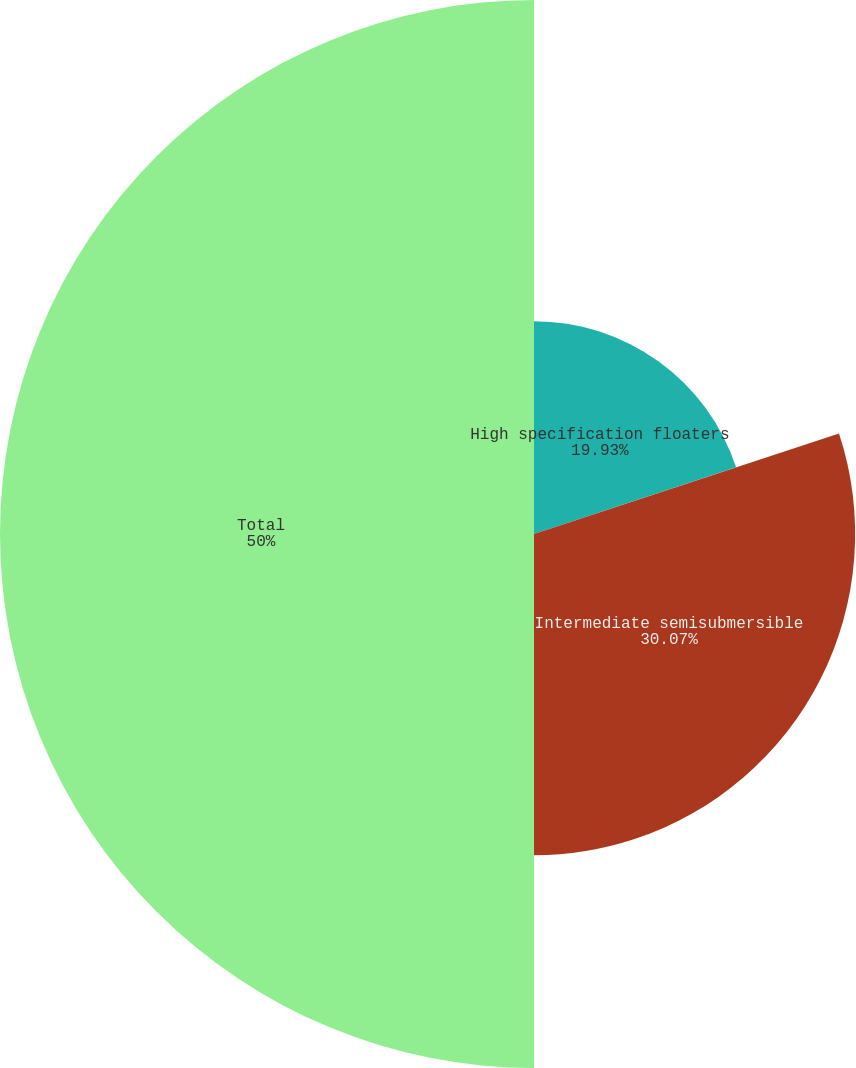Convert chart to OTSL. <chart><loc_0><loc_0><loc_500><loc_500><pie_chart><fcel>High specification floaters<fcel>Intermediate semisubmersible<fcel>Total<nl><fcel>19.93%<fcel>30.07%<fcel>50.0%<nl></chart> 